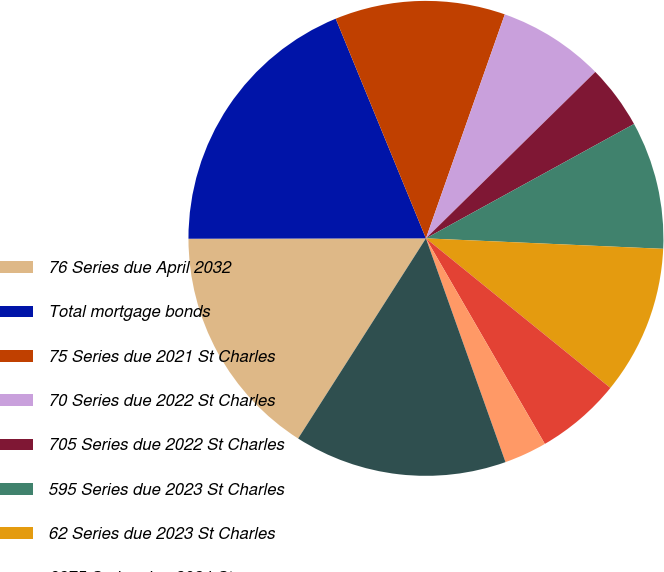Convert chart. <chart><loc_0><loc_0><loc_500><loc_500><pie_chart><fcel>76 Series due April 2032<fcel>Total mortgage bonds<fcel>75 Series due 2021 St Charles<fcel>70 Series due 2022 St Charles<fcel>705 Series due 2022 St Charles<fcel>595 Series due 2023 St Charles<fcel>62 Series due 2023 St Charles<fcel>6875 Series due 2024 St<fcel>6375 Series due 2025 St<fcel>Auction Rate due 2030 St<nl><fcel>15.93%<fcel>18.82%<fcel>11.59%<fcel>7.25%<fcel>4.36%<fcel>8.7%<fcel>10.14%<fcel>5.81%<fcel>2.91%<fcel>14.48%<nl></chart> 